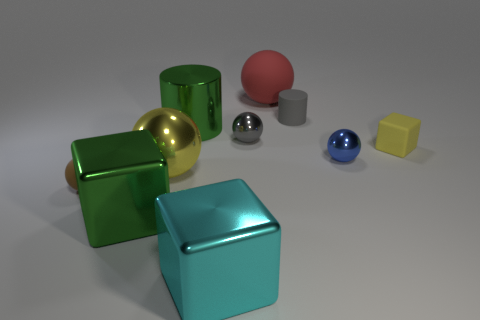Can you describe the arrangement of the objects in the image? The objects are arranged in a staggered manner with varying distances between them. The composition leads your eye from the largest green cube on the left toward the smaller spheres and cubes on the right, creating a sense of balance and contrast in sizes. 